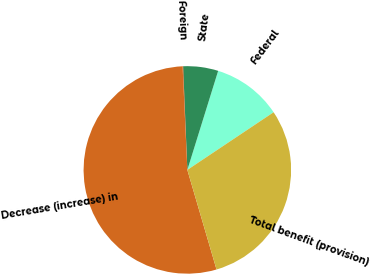<chart> <loc_0><loc_0><loc_500><loc_500><pie_chart><fcel>Federal<fcel>State<fcel>Foreign<fcel>Decrease (increase) in<fcel>Total benefit (provision)<nl><fcel>10.82%<fcel>5.45%<fcel>0.08%<fcel>53.8%<fcel>29.84%<nl></chart> 